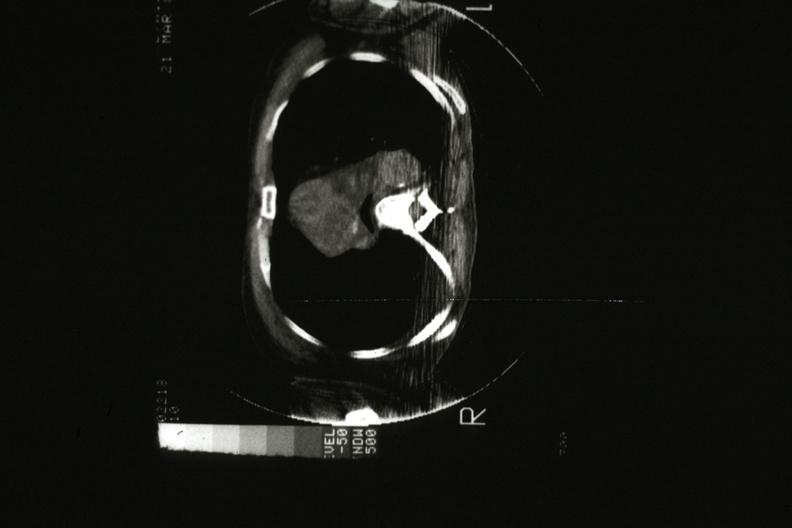does cat scan showing tumor mass invading superior vena ca?
Answer the question using a single word or phrase. Yes 